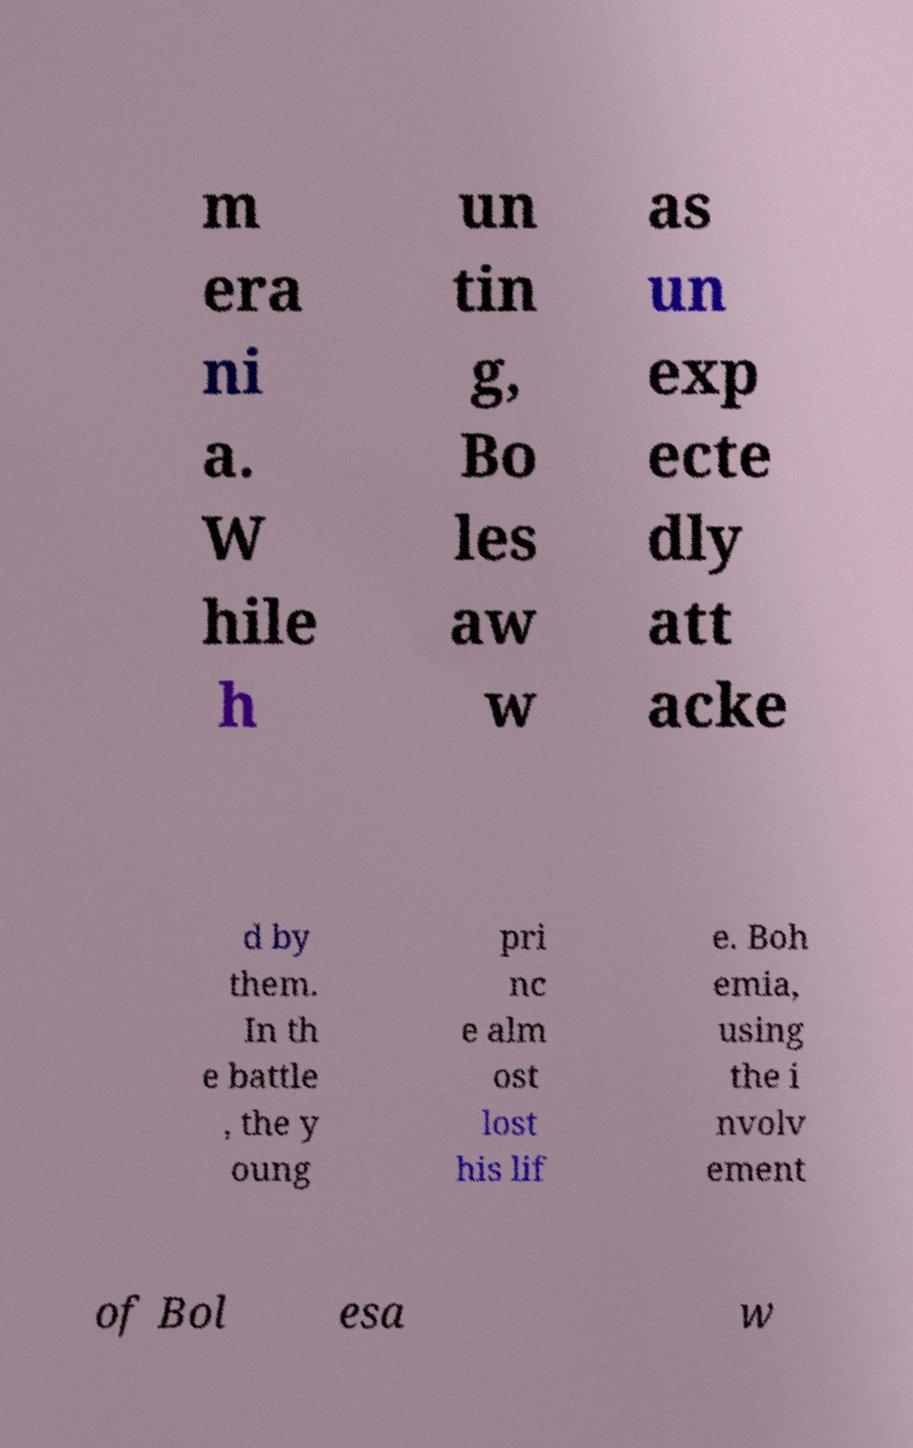Could you assist in decoding the text presented in this image and type it out clearly? m era ni a. W hile h un tin g, Bo les aw w as un exp ecte dly att acke d by them. In th e battle , the y oung pri nc e alm ost lost his lif e. Boh emia, using the i nvolv ement of Bol esa w 